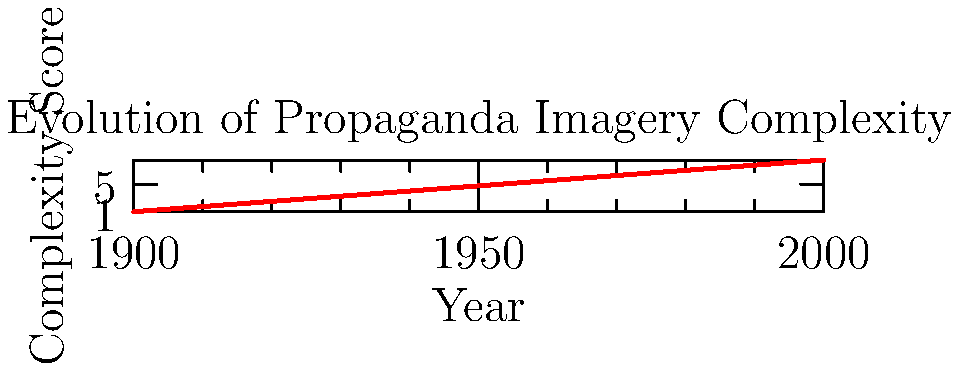Given the graph showing the evolution of propaganda imagery complexity over time, what mathematical model best describes the trend, and how can it be used to predict future complexity scores? To determine the best mathematical model and predict future complexity scores:

1. Observe the trend: The graph shows a relatively consistent increase in complexity over time.

2. Consider potential models:
   a) Linear: $y = mx + b$
   b) Exponential: $y = ae^{bx}$
   c) Polynomial: $y = ax^2 + bx + c$

3. Analyze the curve:
   The increase appears to be slightly more than linear but not quite exponential.

4. Choose the model:
   A quadratic polynomial model ($y = ax^2 + bx + c$) seems most appropriate.

5. Fit the model:
   Using regression analysis (not shown here), we could determine the coefficients $a$, $b$, and $c$.

6. Predict future scores:
   Once we have the equation $y = ax^2 + bx + c$, we can input future years to predict complexity scores.

7. Interpret results:
   The quadratic model suggests an accelerating increase in complexity over time, which aligns with the historical trend of increasingly sophisticated propaganda techniques.
Answer: Quadratic polynomial model: $y = ax^2 + bx + c$ 